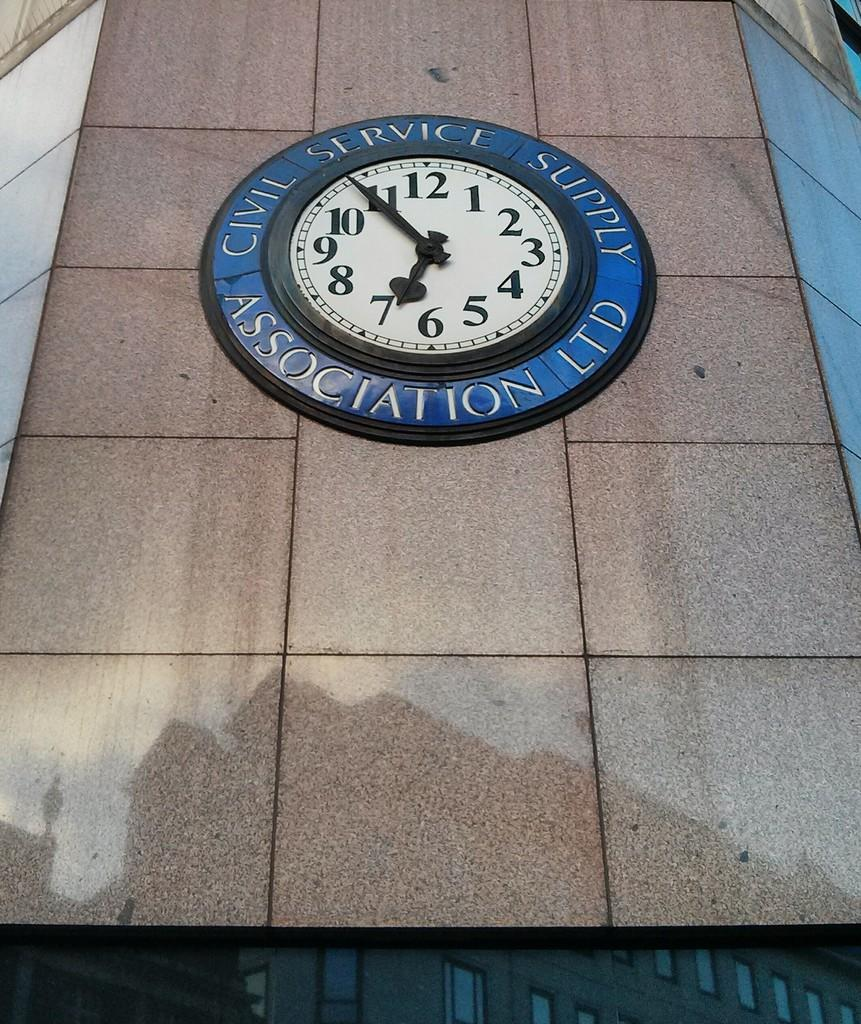What object can be seen in the image that displays time? There is a clock in the image that displays time. Where is the clock located in the image? The clock is attached to a building in the image. What is the color of the building with the clock? The building is in brown color. What type of art can be seen on the building in the image? There is no art visible on the building in the image; it is a plain brown building with a clock attached to it. 